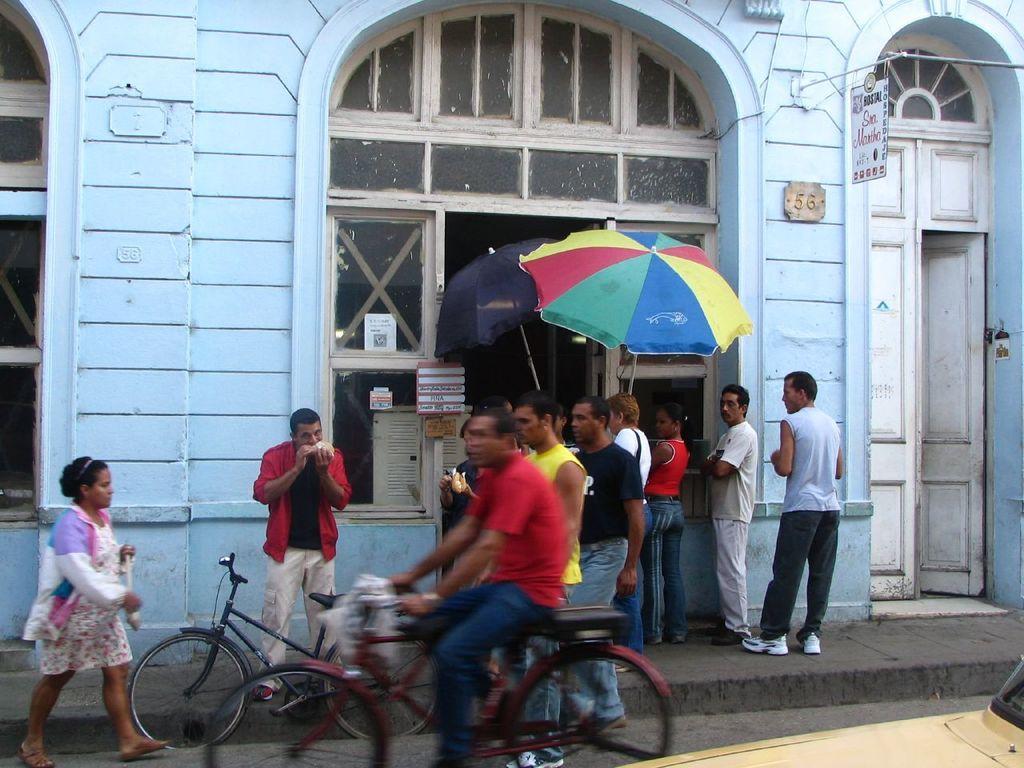How would you summarize this image in a sentence or two? At the bottom of the image there is a person riding a bicycle and also there is a car. Behind that person there is a bicycle. In front of that bicycle there is a lady. Behind them on the footpath there are few people standing. Behind them there is a wall with arched, windows, doors and a board with text on it. 